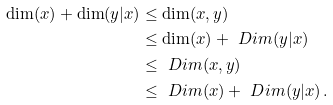<formula> <loc_0><loc_0><loc_500><loc_500>\dim ( x ) + \dim ( y | x ) & \leq \dim ( x , y ) \\ & \leq \dim ( x ) + \ D i m ( y | x ) \\ & \leq \ D i m ( x , y ) \\ & \leq \ D i m ( x ) + \ D i m ( y | x ) \, .</formula> 